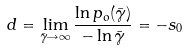<formula> <loc_0><loc_0><loc_500><loc_500>d = \lim _ { \bar { \gamma } \rightarrow \infty } \frac { \ln p _ { o } ( \bar { \gamma } ) } { - \ln \bar { \gamma } } = - s _ { 0 }</formula> 